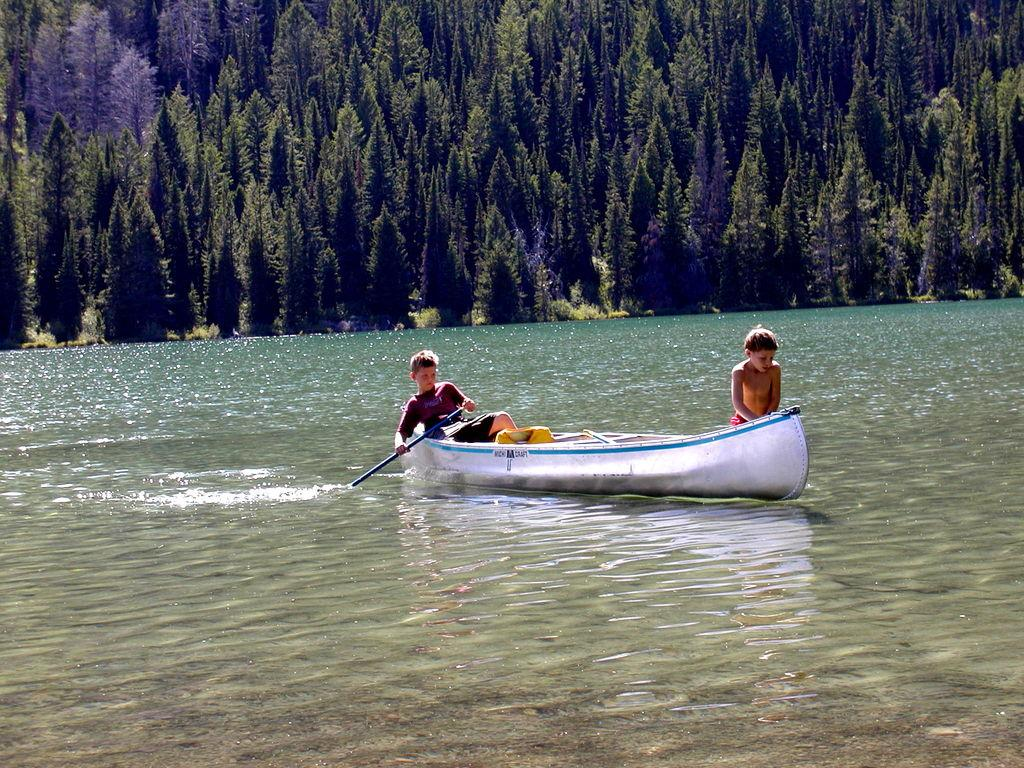What is the main subject of the image? The main subject of the image is water. What is located in the water? There is a boat in the water. Who is in the boat? Two boys are sitting in the boat. What can be seen in the background of the image? There are trees in the background of the image. What type of furniture can be seen in the boat? There is no furniture present in the boat; it only contains two boys. What railway is visible in the image? There is no railway present in the image; it features water, a boat, and two boys. 